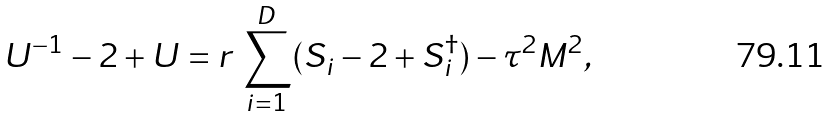<formula> <loc_0><loc_0><loc_500><loc_500>U ^ { - 1 } - 2 + U = r \, \sum ^ { D } _ { i = 1 } ( S _ { i } - 2 + S _ { i } ^ { \dagger } ) - \tau ^ { 2 } M ^ { 2 } ,</formula> 